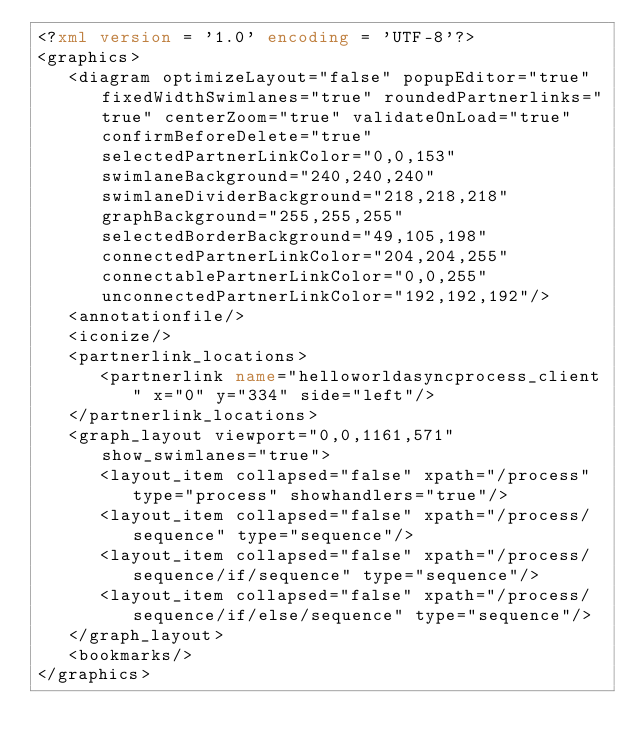Convert code to text. <code><loc_0><loc_0><loc_500><loc_500><_XML_><?xml version = '1.0' encoding = 'UTF-8'?>
<graphics>
   <diagram optimizeLayout="false" popupEditor="true" fixedWidthSwimlanes="true" roundedPartnerlinks="true" centerZoom="true" validateOnLoad="true" confirmBeforeDelete="true" selectedPartnerLinkColor="0,0,153" swimlaneBackground="240,240,240" swimlaneDividerBackground="218,218,218" graphBackground="255,255,255" selectedBorderBackground="49,105,198" connectedPartnerLinkColor="204,204,255" connectablePartnerLinkColor="0,0,255" unconnectedPartnerLinkColor="192,192,192"/>
   <annotationfile/>
   <iconize/>
   <partnerlink_locations>
      <partnerlink name="helloworldasyncprocess_client" x="0" y="334" side="left"/>
   </partnerlink_locations>
   <graph_layout viewport="0,0,1161,571" show_swimlanes="true">
      <layout_item collapsed="false" xpath="/process" type="process" showhandlers="true"/>
      <layout_item collapsed="false" xpath="/process/sequence" type="sequence"/>
      <layout_item collapsed="false" xpath="/process/sequence/if/sequence" type="sequence"/>
      <layout_item collapsed="false" xpath="/process/sequence/if/else/sequence" type="sequence"/>
   </graph_layout>
   <bookmarks/>
</graphics>
</code> 